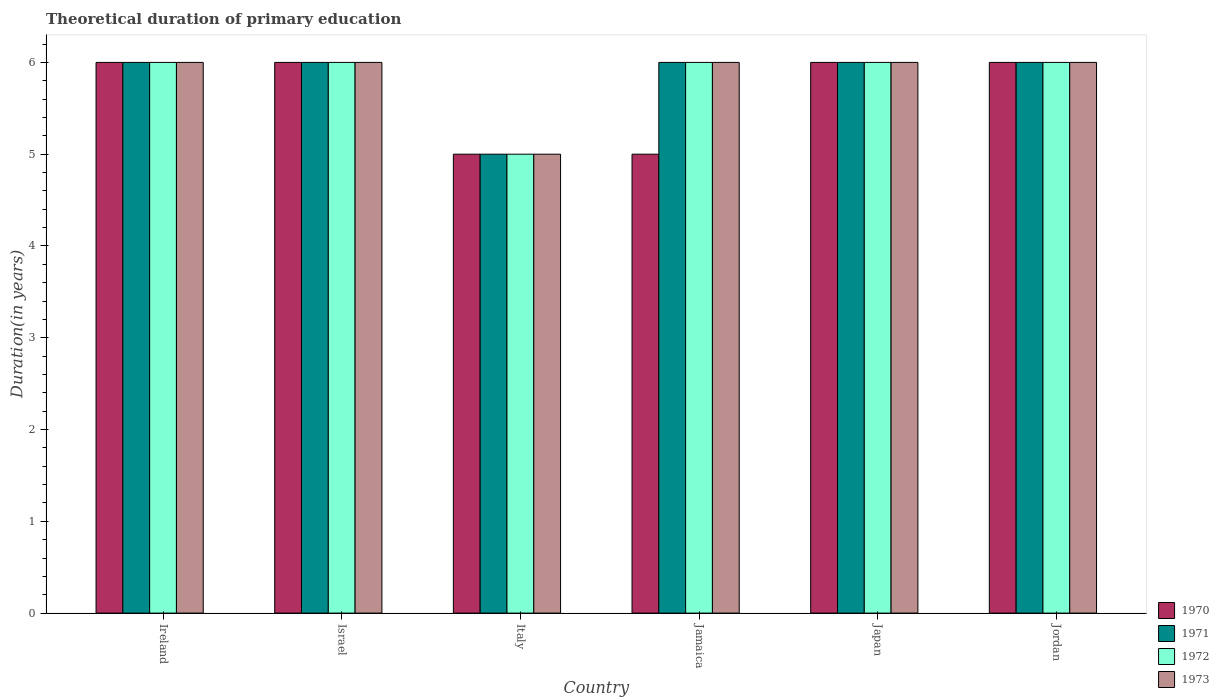How many groups of bars are there?
Your answer should be compact. 6. How many bars are there on the 5th tick from the right?
Give a very brief answer. 4. What is the label of the 1st group of bars from the left?
Your answer should be compact. Ireland. In how many cases, is the number of bars for a given country not equal to the number of legend labels?
Provide a succinct answer. 0. What is the total theoretical duration of primary education in 1971 in Ireland?
Your answer should be very brief. 6. Across all countries, what is the minimum total theoretical duration of primary education in 1972?
Your response must be concise. 5. In which country was the total theoretical duration of primary education in 1972 maximum?
Your answer should be very brief. Ireland. In which country was the total theoretical duration of primary education in 1970 minimum?
Offer a very short reply. Italy. What is the total total theoretical duration of primary education in 1973 in the graph?
Ensure brevity in your answer.  35. What is the difference between the total theoretical duration of primary education in 1970 in Italy and that in Japan?
Offer a terse response. -1. What is the average total theoretical duration of primary education in 1973 per country?
Give a very brief answer. 5.83. In how many countries, is the total theoretical duration of primary education in 1970 greater than 1.2 years?
Provide a succinct answer. 6. Is the total theoretical duration of primary education in 1970 in Israel less than that in Jamaica?
Provide a succinct answer. No. In how many countries, is the total theoretical duration of primary education in 1973 greater than the average total theoretical duration of primary education in 1973 taken over all countries?
Offer a very short reply. 5. What does the 4th bar from the right in Ireland represents?
Offer a terse response. 1970. Is it the case that in every country, the sum of the total theoretical duration of primary education in 1970 and total theoretical duration of primary education in 1971 is greater than the total theoretical duration of primary education in 1973?
Provide a short and direct response. Yes. Does the graph contain any zero values?
Offer a very short reply. No. Does the graph contain grids?
Give a very brief answer. No. Where does the legend appear in the graph?
Keep it short and to the point. Bottom right. How many legend labels are there?
Provide a succinct answer. 4. How are the legend labels stacked?
Your response must be concise. Vertical. What is the title of the graph?
Keep it short and to the point. Theoretical duration of primary education. What is the label or title of the Y-axis?
Make the answer very short. Duration(in years). What is the Duration(in years) in 1971 in Ireland?
Ensure brevity in your answer.  6. What is the Duration(in years) in 1973 in Ireland?
Keep it short and to the point. 6. What is the Duration(in years) of 1972 in Italy?
Your answer should be compact. 5. What is the Duration(in years) in 1973 in Italy?
Give a very brief answer. 5. What is the Duration(in years) of 1970 in Jamaica?
Your answer should be very brief. 5. What is the Duration(in years) of 1973 in Jamaica?
Keep it short and to the point. 6. What is the Duration(in years) of 1970 in Japan?
Offer a terse response. 6. What is the Duration(in years) in 1971 in Jordan?
Provide a succinct answer. 6. What is the Duration(in years) in 1973 in Jordan?
Ensure brevity in your answer.  6. Across all countries, what is the maximum Duration(in years) of 1972?
Provide a short and direct response. 6. Across all countries, what is the minimum Duration(in years) in 1970?
Make the answer very short. 5. Across all countries, what is the minimum Duration(in years) of 1971?
Provide a succinct answer. 5. Across all countries, what is the minimum Duration(in years) of 1972?
Keep it short and to the point. 5. What is the total Duration(in years) in 1971 in the graph?
Provide a short and direct response. 35. What is the total Duration(in years) of 1972 in the graph?
Ensure brevity in your answer.  35. What is the total Duration(in years) in 1973 in the graph?
Offer a very short reply. 35. What is the difference between the Duration(in years) of 1973 in Ireland and that in Israel?
Make the answer very short. 0. What is the difference between the Duration(in years) in 1971 in Ireland and that in Italy?
Make the answer very short. 1. What is the difference between the Duration(in years) in 1973 in Ireland and that in Italy?
Give a very brief answer. 1. What is the difference between the Duration(in years) of 1971 in Ireland and that in Japan?
Offer a very short reply. 0. What is the difference between the Duration(in years) in 1972 in Ireland and that in Japan?
Give a very brief answer. 0. What is the difference between the Duration(in years) in 1973 in Ireland and that in Japan?
Provide a succinct answer. 0. What is the difference between the Duration(in years) of 1971 in Ireland and that in Jordan?
Offer a very short reply. 0. What is the difference between the Duration(in years) of 1972 in Ireland and that in Jordan?
Provide a short and direct response. 0. What is the difference between the Duration(in years) in 1973 in Ireland and that in Jordan?
Make the answer very short. 0. What is the difference between the Duration(in years) in 1971 in Israel and that in Italy?
Your answer should be very brief. 1. What is the difference between the Duration(in years) of 1973 in Israel and that in Italy?
Your response must be concise. 1. What is the difference between the Duration(in years) in 1970 in Israel and that in Jamaica?
Your answer should be very brief. 1. What is the difference between the Duration(in years) in 1971 in Israel and that in Jamaica?
Your answer should be compact. 0. What is the difference between the Duration(in years) in 1972 in Israel and that in Jamaica?
Give a very brief answer. 0. What is the difference between the Duration(in years) in 1970 in Israel and that in Japan?
Provide a succinct answer. 0. What is the difference between the Duration(in years) of 1971 in Israel and that in Japan?
Offer a very short reply. 0. What is the difference between the Duration(in years) in 1973 in Israel and that in Japan?
Offer a very short reply. 0. What is the difference between the Duration(in years) of 1970 in Israel and that in Jordan?
Your answer should be compact. 0. What is the difference between the Duration(in years) in 1972 in Israel and that in Jordan?
Your response must be concise. 0. What is the difference between the Duration(in years) of 1971 in Italy and that in Jamaica?
Offer a terse response. -1. What is the difference between the Duration(in years) of 1973 in Italy and that in Jamaica?
Give a very brief answer. -1. What is the difference between the Duration(in years) of 1970 in Italy and that in Japan?
Your answer should be compact. -1. What is the difference between the Duration(in years) in 1973 in Italy and that in Japan?
Provide a succinct answer. -1. What is the difference between the Duration(in years) in 1972 in Italy and that in Jordan?
Keep it short and to the point. -1. What is the difference between the Duration(in years) of 1971 in Jamaica and that in Jordan?
Provide a short and direct response. 0. What is the difference between the Duration(in years) in 1973 in Jamaica and that in Jordan?
Give a very brief answer. 0. What is the difference between the Duration(in years) in 1973 in Japan and that in Jordan?
Your answer should be compact. 0. What is the difference between the Duration(in years) of 1970 in Ireland and the Duration(in years) of 1971 in Israel?
Your response must be concise. 0. What is the difference between the Duration(in years) of 1970 in Ireland and the Duration(in years) of 1972 in Israel?
Your response must be concise. 0. What is the difference between the Duration(in years) of 1971 in Ireland and the Duration(in years) of 1972 in Israel?
Provide a succinct answer. 0. What is the difference between the Duration(in years) in 1971 in Ireland and the Duration(in years) in 1973 in Israel?
Offer a very short reply. 0. What is the difference between the Duration(in years) in 1971 in Ireland and the Duration(in years) in 1972 in Italy?
Your answer should be compact. 1. What is the difference between the Duration(in years) of 1972 in Ireland and the Duration(in years) of 1973 in Italy?
Provide a succinct answer. 1. What is the difference between the Duration(in years) of 1970 in Ireland and the Duration(in years) of 1972 in Jamaica?
Ensure brevity in your answer.  0. What is the difference between the Duration(in years) in 1971 in Ireland and the Duration(in years) in 1972 in Jamaica?
Make the answer very short. 0. What is the difference between the Duration(in years) in 1971 in Ireland and the Duration(in years) in 1973 in Jamaica?
Ensure brevity in your answer.  0. What is the difference between the Duration(in years) of 1972 in Ireland and the Duration(in years) of 1973 in Jamaica?
Your answer should be very brief. 0. What is the difference between the Duration(in years) in 1970 in Ireland and the Duration(in years) in 1973 in Japan?
Your answer should be compact. 0. What is the difference between the Duration(in years) of 1971 in Ireland and the Duration(in years) of 1972 in Japan?
Your answer should be compact. 0. What is the difference between the Duration(in years) of 1971 in Ireland and the Duration(in years) of 1973 in Japan?
Provide a short and direct response. 0. What is the difference between the Duration(in years) of 1972 in Ireland and the Duration(in years) of 1973 in Japan?
Offer a very short reply. 0. What is the difference between the Duration(in years) of 1970 in Ireland and the Duration(in years) of 1972 in Jordan?
Keep it short and to the point. 0. What is the difference between the Duration(in years) of 1971 in Ireland and the Duration(in years) of 1972 in Jordan?
Keep it short and to the point. 0. What is the difference between the Duration(in years) in 1971 in Ireland and the Duration(in years) in 1973 in Jordan?
Make the answer very short. 0. What is the difference between the Duration(in years) in 1970 in Israel and the Duration(in years) in 1971 in Italy?
Provide a succinct answer. 1. What is the difference between the Duration(in years) of 1970 in Israel and the Duration(in years) of 1972 in Italy?
Ensure brevity in your answer.  1. What is the difference between the Duration(in years) in 1971 in Israel and the Duration(in years) in 1972 in Italy?
Your answer should be very brief. 1. What is the difference between the Duration(in years) of 1971 in Israel and the Duration(in years) of 1973 in Italy?
Offer a terse response. 1. What is the difference between the Duration(in years) in 1970 in Israel and the Duration(in years) in 1972 in Jamaica?
Your answer should be very brief. 0. What is the difference between the Duration(in years) in 1971 in Israel and the Duration(in years) in 1972 in Jamaica?
Keep it short and to the point. 0. What is the difference between the Duration(in years) of 1970 in Israel and the Duration(in years) of 1971 in Japan?
Ensure brevity in your answer.  0. What is the difference between the Duration(in years) of 1970 in Israel and the Duration(in years) of 1972 in Japan?
Keep it short and to the point. 0. What is the difference between the Duration(in years) of 1972 in Israel and the Duration(in years) of 1973 in Japan?
Ensure brevity in your answer.  0. What is the difference between the Duration(in years) of 1970 in Israel and the Duration(in years) of 1971 in Jordan?
Offer a terse response. 0. What is the difference between the Duration(in years) of 1970 in Israel and the Duration(in years) of 1972 in Jordan?
Make the answer very short. 0. What is the difference between the Duration(in years) in 1970 in Israel and the Duration(in years) in 1973 in Jordan?
Offer a terse response. 0. What is the difference between the Duration(in years) in 1971 in Israel and the Duration(in years) in 1972 in Jordan?
Offer a very short reply. 0. What is the difference between the Duration(in years) in 1971 in Israel and the Duration(in years) in 1973 in Jordan?
Your response must be concise. 0. What is the difference between the Duration(in years) of 1970 in Italy and the Duration(in years) of 1972 in Jamaica?
Your answer should be compact. -1. What is the difference between the Duration(in years) in 1970 in Italy and the Duration(in years) in 1973 in Jamaica?
Keep it short and to the point. -1. What is the difference between the Duration(in years) of 1971 in Italy and the Duration(in years) of 1973 in Jamaica?
Your response must be concise. -1. What is the difference between the Duration(in years) of 1970 in Italy and the Duration(in years) of 1973 in Japan?
Give a very brief answer. -1. What is the difference between the Duration(in years) of 1971 in Italy and the Duration(in years) of 1972 in Japan?
Offer a terse response. -1. What is the difference between the Duration(in years) of 1970 in Jamaica and the Duration(in years) of 1971 in Japan?
Offer a very short reply. -1. What is the difference between the Duration(in years) in 1970 in Jamaica and the Duration(in years) in 1972 in Japan?
Make the answer very short. -1. What is the difference between the Duration(in years) of 1971 in Jamaica and the Duration(in years) of 1972 in Japan?
Provide a short and direct response. 0. What is the difference between the Duration(in years) in 1972 in Jamaica and the Duration(in years) in 1973 in Japan?
Your answer should be very brief. 0. What is the difference between the Duration(in years) in 1970 in Jamaica and the Duration(in years) in 1972 in Jordan?
Make the answer very short. -1. What is the difference between the Duration(in years) in 1970 in Jamaica and the Duration(in years) in 1973 in Jordan?
Provide a succinct answer. -1. What is the difference between the Duration(in years) of 1971 in Jamaica and the Duration(in years) of 1973 in Jordan?
Offer a terse response. 0. What is the difference between the Duration(in years) of 1970 in Japan and the Duration(in years) of 1972 in Jordan?
Offer a very short reply. 0. What is the difference between the Duration(in years) in 1970 in Japan and the Duration(in years) in 1973 in Jordan?
Give a very brief answer. 0. What is the difference between the Duration(in years) of 1971 in Japan and the Duration(in years) of 1972 in Jordan?
Provide a succinct answer. 0. What is the difference between the Duration(in years) in 1971 in Japan and the Duration(in years) in 1973 in Jordan?
Offer a terse response. 0. What is the average Duration(in years) in 1970 per country?
Offer a terse response. 5.67. What is the average Duration(in years) in 1971 per country?
Keep it short and to the point. 5.83. What is the average Duration(in years) of 1972 per country?
Your answer should be very brief. 5.83. What is the average Duration(in years) of 1973 per country?
Ensure brevity in your answer.  5.83. What is the difference between the Duration(in years) of 1971 and Duration(in years) of 1973 in Ireland?
Offer a terse response. 0. What is the difference between the Duration(in years) of 1970 and Duration(in years) of 1971 in Israel?
Give a very brief answer. 0. What is the difference between the Duration(in years) of 1972 and Duration(in years) of 1973 in Israel?
Your response must be concise. 0. What is the difference between the Duration(in years) of 1970 and Duration(in years) of 1972 in Italy?
Offer a very short reply. 0. What is the difference between the Duration(in years) of 1971 and Duration(in years) of 1973 in Italy?
Keep it short and to the point. 0. What is the difference between the Duration(in years) of 1972 and Duration(in years) of 1973 in Italy?
Provide a short and direct response. 0. What is the difference between the Duration(in years) in 1970 and Duration(in years) in 1971 in Jamaica?
Ensure brevity in your answer.  -1. What is the difference between the Duration(in years) in 1970 and Duration(in years) in 1972 in Jamaica?
Provide a short and direct response. -1. What is the difference between the Duration(in years) of 1970 and Duration(in years) of 1973 in Jamaica?
Offer a very short reply. -1. What is the difference between the Duration(in years) in 1971 and Duration(in years) in 1972 in Jamaica?
Make the answer very short. 0. What is the difference between the Duration(in years) in 1970 and Duration(in years) in 1971 in Japan?
Provide a short and direct response. 0. What is the difference between the Duration(in years) of 1970 and Duration(in years) of 1972 in Japan?
Offer a terse response. 0. What is the difference between the Duration(in years) of 1970 and Duration(in years) of 1973 in Japan?
Your answer should be compact. 0. What is the difference between the Duration(in years) in 1971 and Duration(in years) in 1973 in Japan?
Offer a terse response. 0. What is the difference between the Duration(in years) in 1970 and Duration(in years) in 1972 in Jordan?
Make the answer very short. 0. What is the difference between the Duration(in years) of 1970 and Duration(in years) of 1973 in Jordan?
Your response must be concise. 0. What is the difference between the Duration(in years) in 1971 and Duration(in years) in 1972 in Jordan?
Offer a terse response. 0. What is the ratio of the Duration(in years) in 1972 in Ireland to that in Israel?
Keep it short and to the point. 1. What is the ratio of the Duration(in years) in 1973 in Ireland to that in Israel?
Offer a very short reply. 1. What is the ratio of the Duration(in years) of 1970 in Ireland to that in Italy?
Offer a terse response. 1.2. What is the ratio of the Duration(in years) of 1971 in Ireland to that in Jamaica?
Provide a short and direct response. 1. What is the ratio of the Duration(in years) in 1972 in Ireland to that in Jamaica?
Provide a succinct answer. 1. What is the ratio of the Duration(in years) in 1970 in Ireland to that in Japan?
Ensure brevity in your answer.  1. What is the ratio of the Duration(in years) in 1971 in Ireland to that in Japan?
Your answer should be very brief. 1. What is the ratio of the Duration(in years) in 1970 in Ireland to that in Jordan?
Provide a short and direct response. 1. What is the ratio of the Duration(in years) of 1972 in Ireland to that in Jordan?
Your answer should be very brief. 1. What is the ratio of the Duration(in years) in 1973 in Ireland to that in Jordan?
Your response must be concise. 1. What is the ratio of the Duration(in years) of 1970 in Israel to that in Italy?
Make the answer very short. 1.2. What is the ratio of the Duration(in years) in 1970 in Israel to that in Jamaica?
Your response must be concise. 1.2. What is the ratio of the Duration(in years) in 1973 in Israel to that in Jamaica?
Keep it short and to the point. 1. What is the ratio of the Duration(in years) in 1970 in Israel to that in Japan?
Your answer should be compact. 1. What is the ratio of the Duration(in years) in 1971 in Israel to that in Japan?
Offer a very short reply. 1. What is the ratio of the Duration(in years) in 1972 in Israel to that in Japan?
Offer a terse response. 1. What is the ratio of the Duration(in years) of 1973 in Israel to that in Japan?
Ensure brevity in your answer.  1. What is the ratio of the Duration(in years) in 1970 in Israel to that in Jordan?
Your answer should be very brief. 1. What is the ratio of the Duration(in years) of 1971 in Israel to that in Jordan?
Offer a very short reply. 1. What is the ratio of the Duration(in years) of 1972 in Israel to that in Jordan?
Provide a succinct answer. 1. What is the ratio of the Duration(in years) in 1970 in Italy to that in Jamaica?
Give a very brief answer. 1. What is the ratio of the Duration(in years) in 1971 in Italy to that in Jamaica?
Keep it short and to the point. 0.83. What is the ratio of the Duration(in years) of 1973 in Italy to that in Jamaica?
Your answer should be compact. 0.83. What is the ratio of the Duration(in years) in 1970 in Italy to that in Japan?
Provide a short and direct response. 0.83. What is the ratio of the Duration(in years) in 1971 in Italy to that in Japan?
Ensure brevity in your answer.  0.83. What is the ratio of the Duration(in years) in 1973 in Italy to that in Japan?
Keep it short and to the point. 0.83. What is the ratio of the Duration(in years) in 1970 in Italy to that in Jordan?
Offer a very short reply. 0.83. What is the ratio of the Duration(in years) of 1971 in Italy to that in Jordan?
Make the answer very short. 0.83. What is the ratio of the Duration(in years) in 1972 in Jamaica to that in Japan?
Keep it short and to the point. 1. What is the ratio of the Duration(in years) of 1973 in Jamaica to that in Japan?
Keep it short and to the point. 1. What is the ratio of the Duration(in years) of 1971 in Jamaica to that in Jordan?
Provide a short and direct response. 1. What is the ratio of the Duration(in years) in 1973 in Jamaica to that in Jordan?
Offer a very short reply. 1. What is the ratio of the Duration(in years) in 1970 in Japan to that in Jordan?
Provide a short and direct response. 1. What is the ratio of the Duration(in years) in 1971 in Japan to that in Jordan?
Your answer should be very brief. 1. What is the ratio of the Duration(in years) in 1972 in Japan to that in Jordan?
Keep it short and to the point. 1. What is the difference between the highest and the second highest Duration(in years) in 1973?
Give a very brief answer. 0. What is the difference between the highest and the lowest Duration(in years) in 1971?
Your answer should be very brief. 1. What is the difference between the highest and the lowest Duration(in years) in 1973?
Give a very brief answer. 1. 